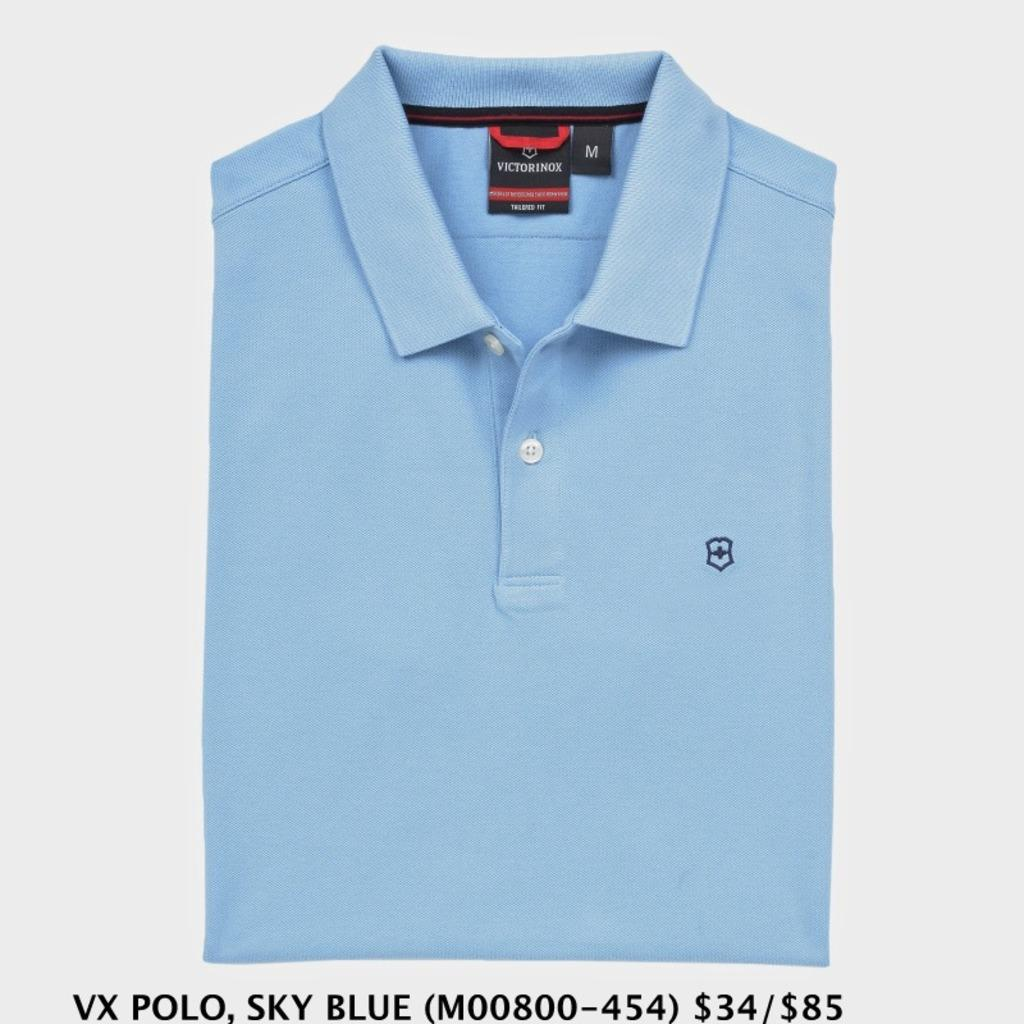<image>
Summarize the visual content of the image. VX Polo, Sky Blue, $34/$85 reads the caption of this shirt advert. 